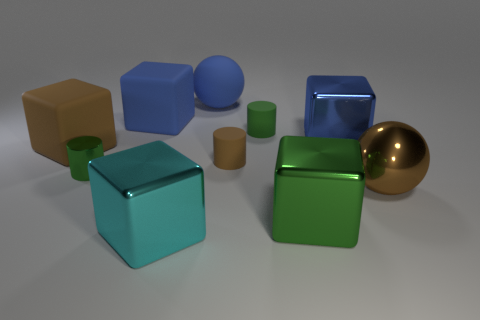Subtract all brown blocks. How many blocks are left? 4 Subtract all gray cylinders. How many blue blocks are left? 2 Subtract all cyan blocks. How many blocks are left? 4 Subtract 2 blocks. How many blocks are left? 3 Subtract all red cylinders. Subtract all cyan balls. How many cylinders are left? 3 Subtract all spheres. How many objects are left? 8 Subtract all tiny brown matte cylinders. Subtract all blue cubes. How many objects are left? 7 Add 9 metal cylinders. How many metal cylinders are left? 10 Add 4 small brown rubber objects. How many small brown rubber objects exist? 5 Subtract 1 cyan cubes. How many objects are left? 9 